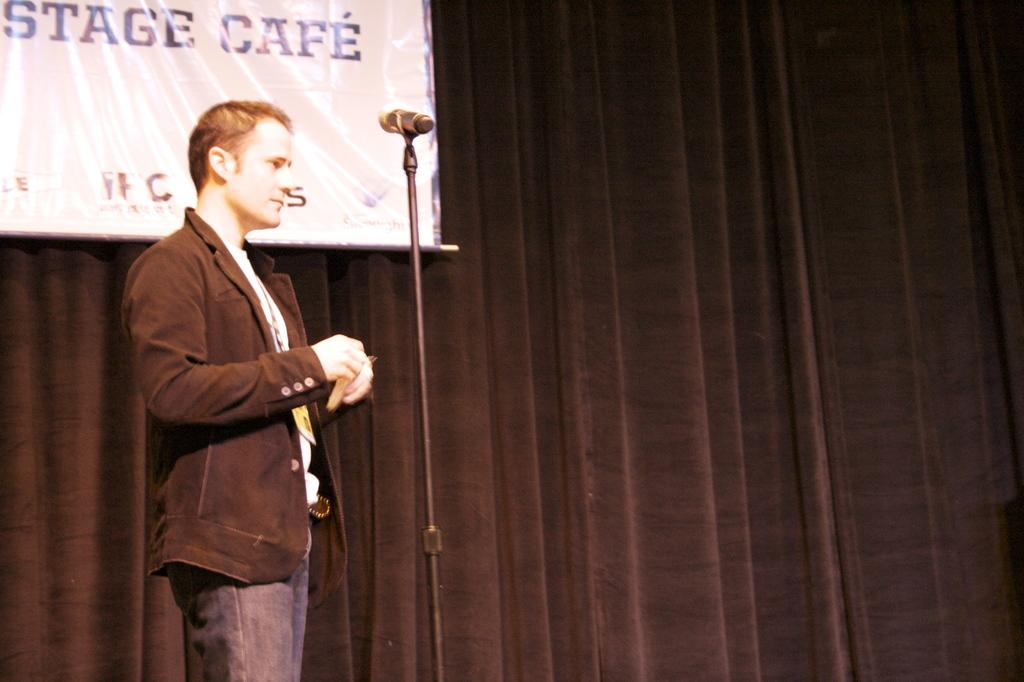What is the main subject of the image? There is a person standing in the image. What object is present that is typically used for amplifying sound? There is a microphone with a microphone stand in the image. What type of fabric is present in the image? There is a curtain in the image. What is the purpose of the banner in the image? The purpose of the banner in the image is to convey a message or provide information. What type of trade is being conducted in the image? There is no trade being conducted in the image; it features a person standing with a microphone, a curtain, and a banner. How does the rainstorm affect the person in the image? There is no rainstorm present in the image; it is an indoor setting with a person, a microphone, a curtain, and a banner. 